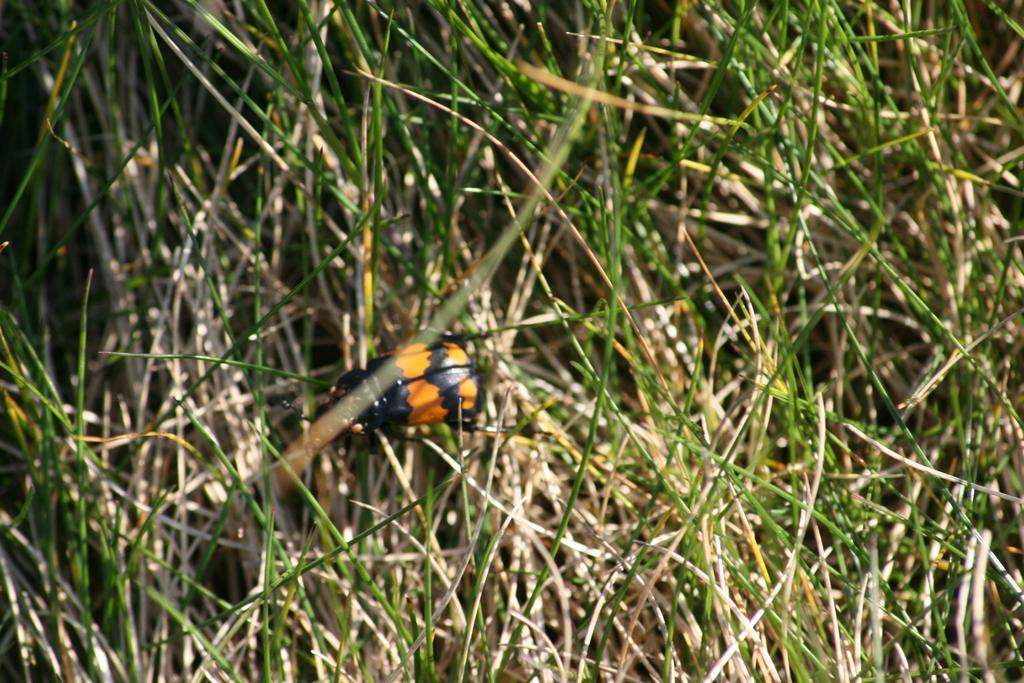What type of creature is in the image? There is an insect in the image. What colors can be seen on the insect? The insect is black and orange in color. What type of vegetation is in the image? There is grass in the image. What colors can be seen on the grass? The grass is green, cream, and brown in color. What is the price of the balls in the image? There are no balls present in the image, so it is not possible to determine the price. 